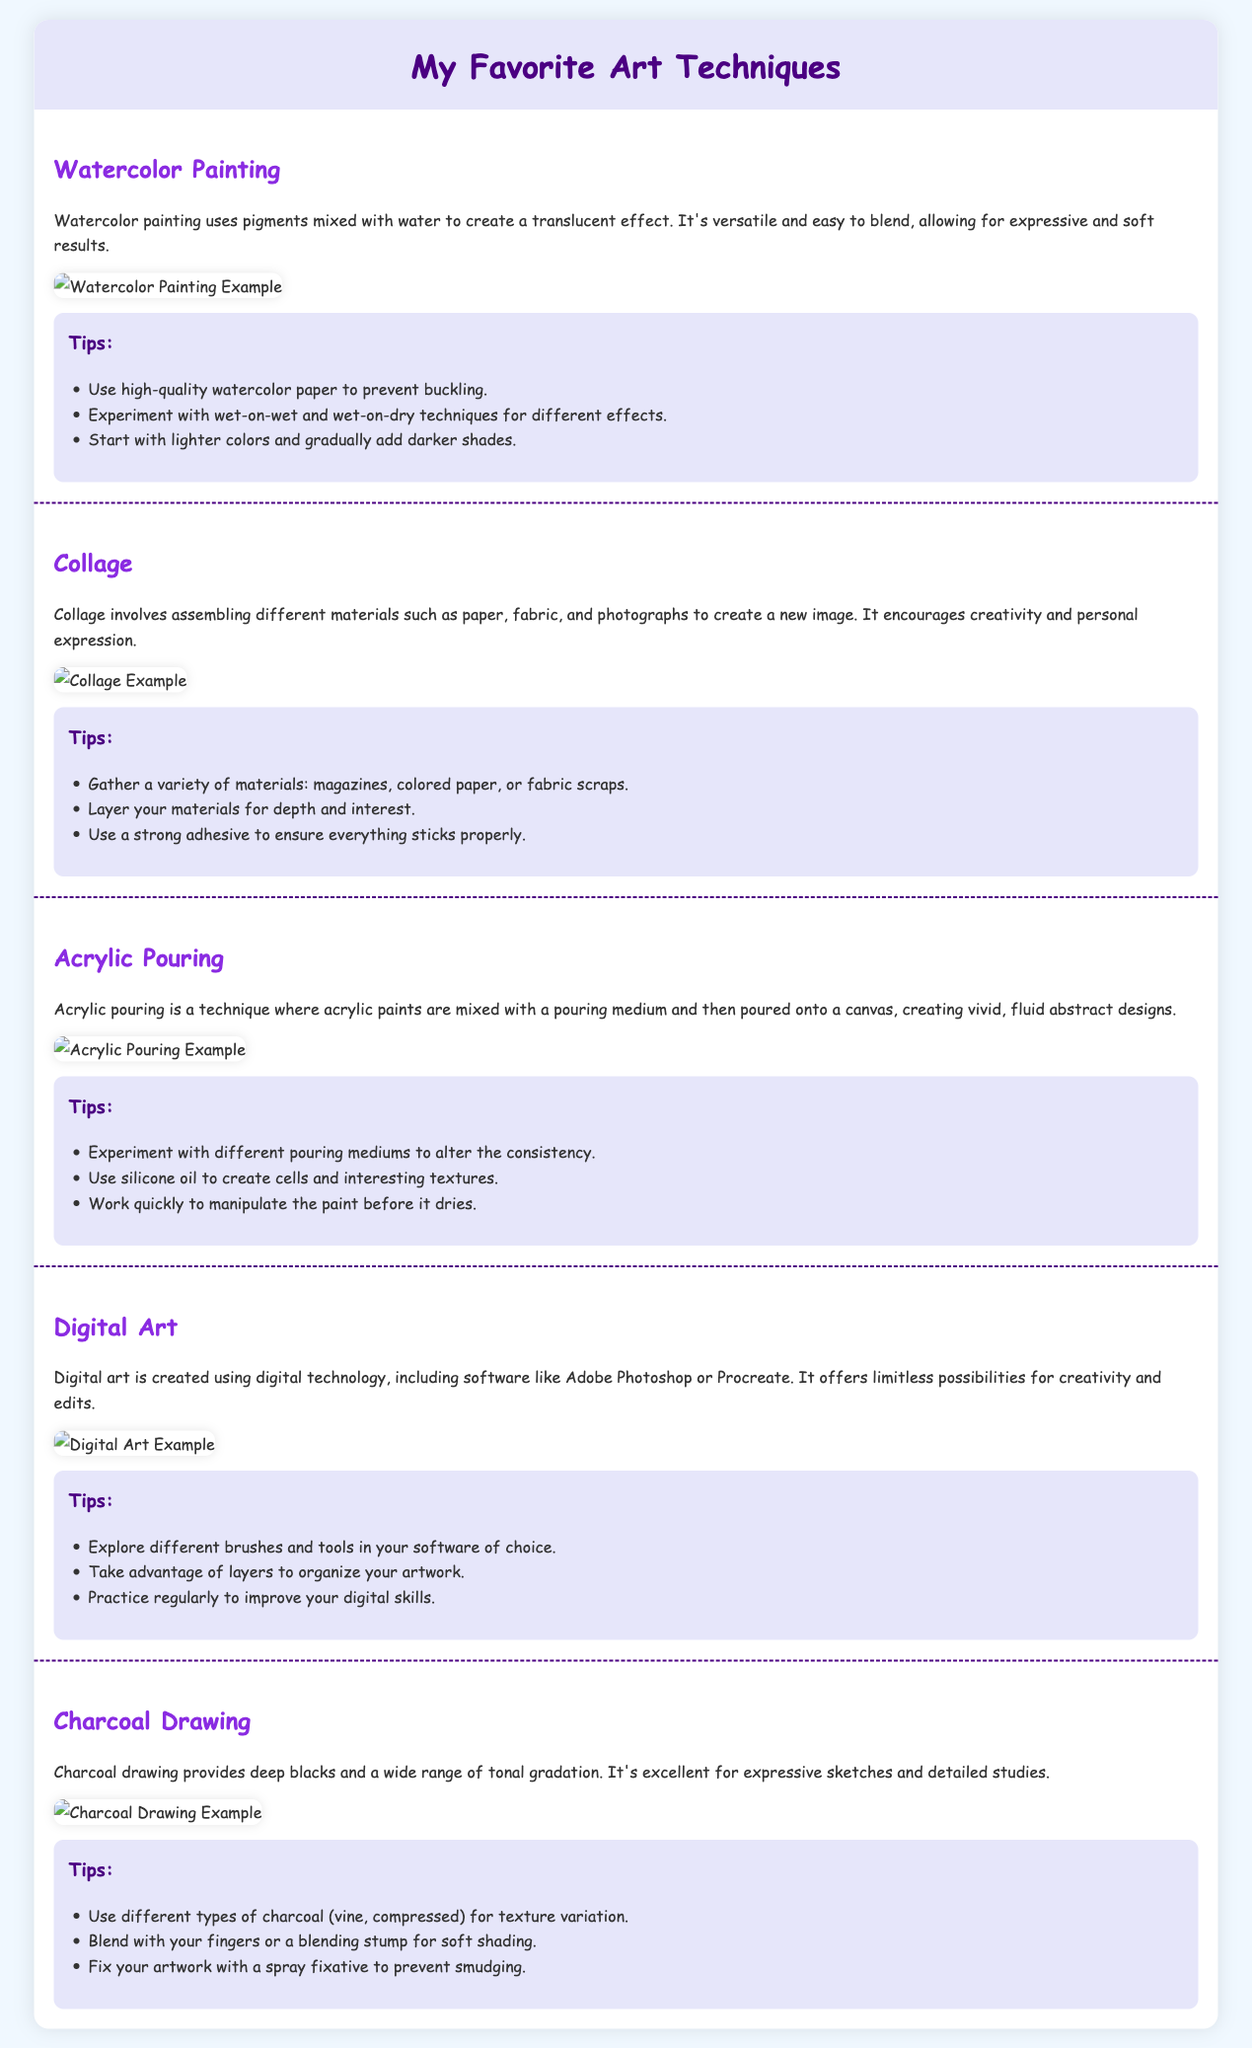What is the first art technique listed? The first technique in the document is Watercolor Painting.
Answer: Watercolor Painting How many art techniques are described in the document? There are a total of five techniques described in the document.
Answer: Five What is a key tip for Acrylic Pouring? One of the tips provided for Acrylic Pouring is to experiment with different pouring mediums.
Answer: Experiment with different pouring mediums What is the main characteristic of Charcoal Drawing? Charcoal drawing is noted for providing deep blacks and a wide range of tonal gradation.
Answer: Deep blacks and tonal gradation What technique encourages personal expression through material assembly? The technique that involves assembling materials for creating a new image is Collage.
Answer: Collage Which technique uses digital technology? Digital Art is the technique that is created using digital technology including software.
Answer: Digital Art What kind of effect is achieved with Watercolor Painting? Watercolor painting achieves a translucent effect.
Answer: Translucent effect Which technique is best for expressive sketches? The technique best suited for expressive sketches is Charcoal Drawing.
Answer: Charcoal Drawing 